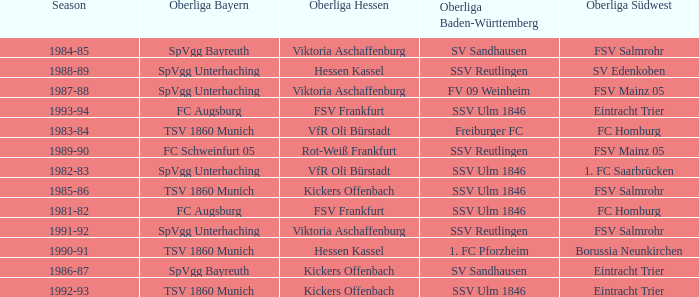Which oberliga baden-württemberg has a season of 1991-92? SSV Reutlingen. 